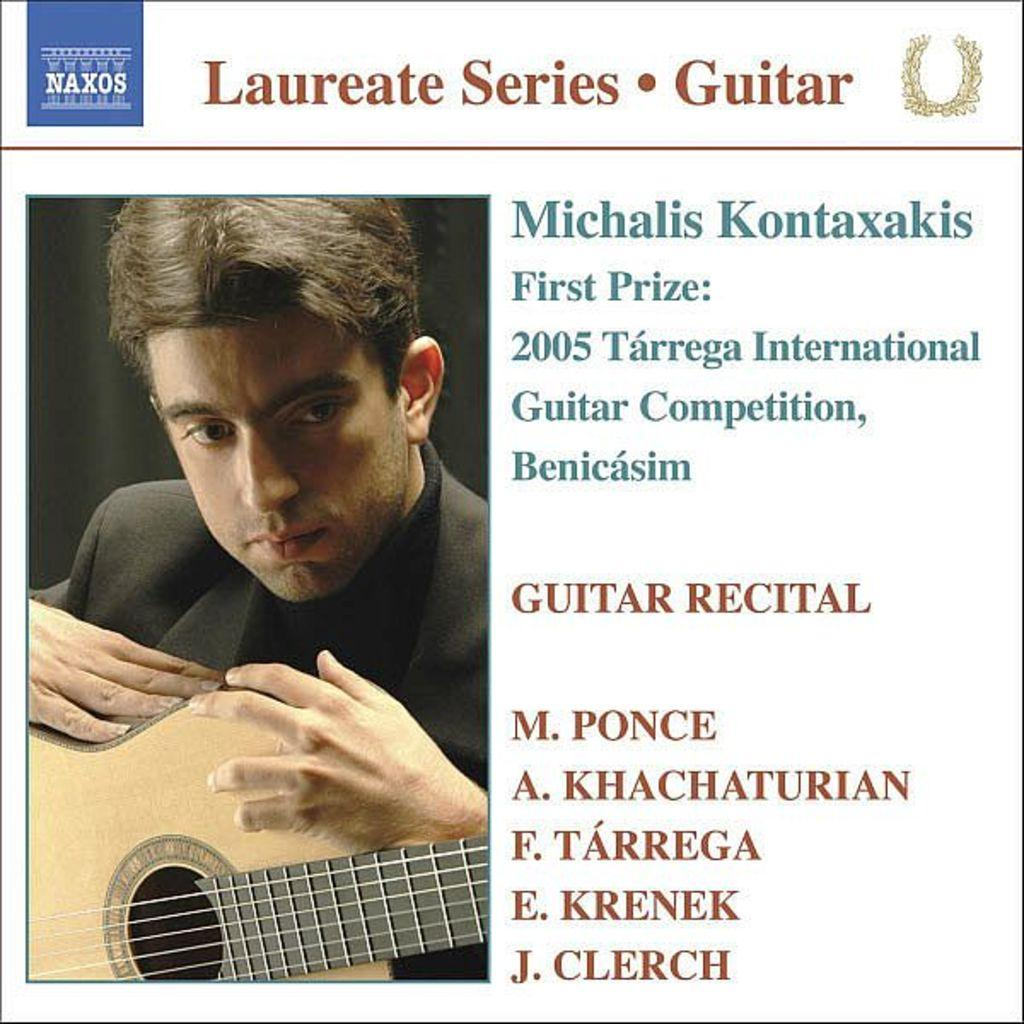Who is present in the image? There is a man in the image. What is the man holding in the image? The man is holding a music instrument. Can you describe the music instrument? The music instrument is yellow in color. What else can be seen in the image besides the man and the music instrument? There is printed text in the image. What type of fan is visible in the image? There is no fan present in the image. What class is the man attending in the image? The image does not provide any information about a class or any educational setting. 